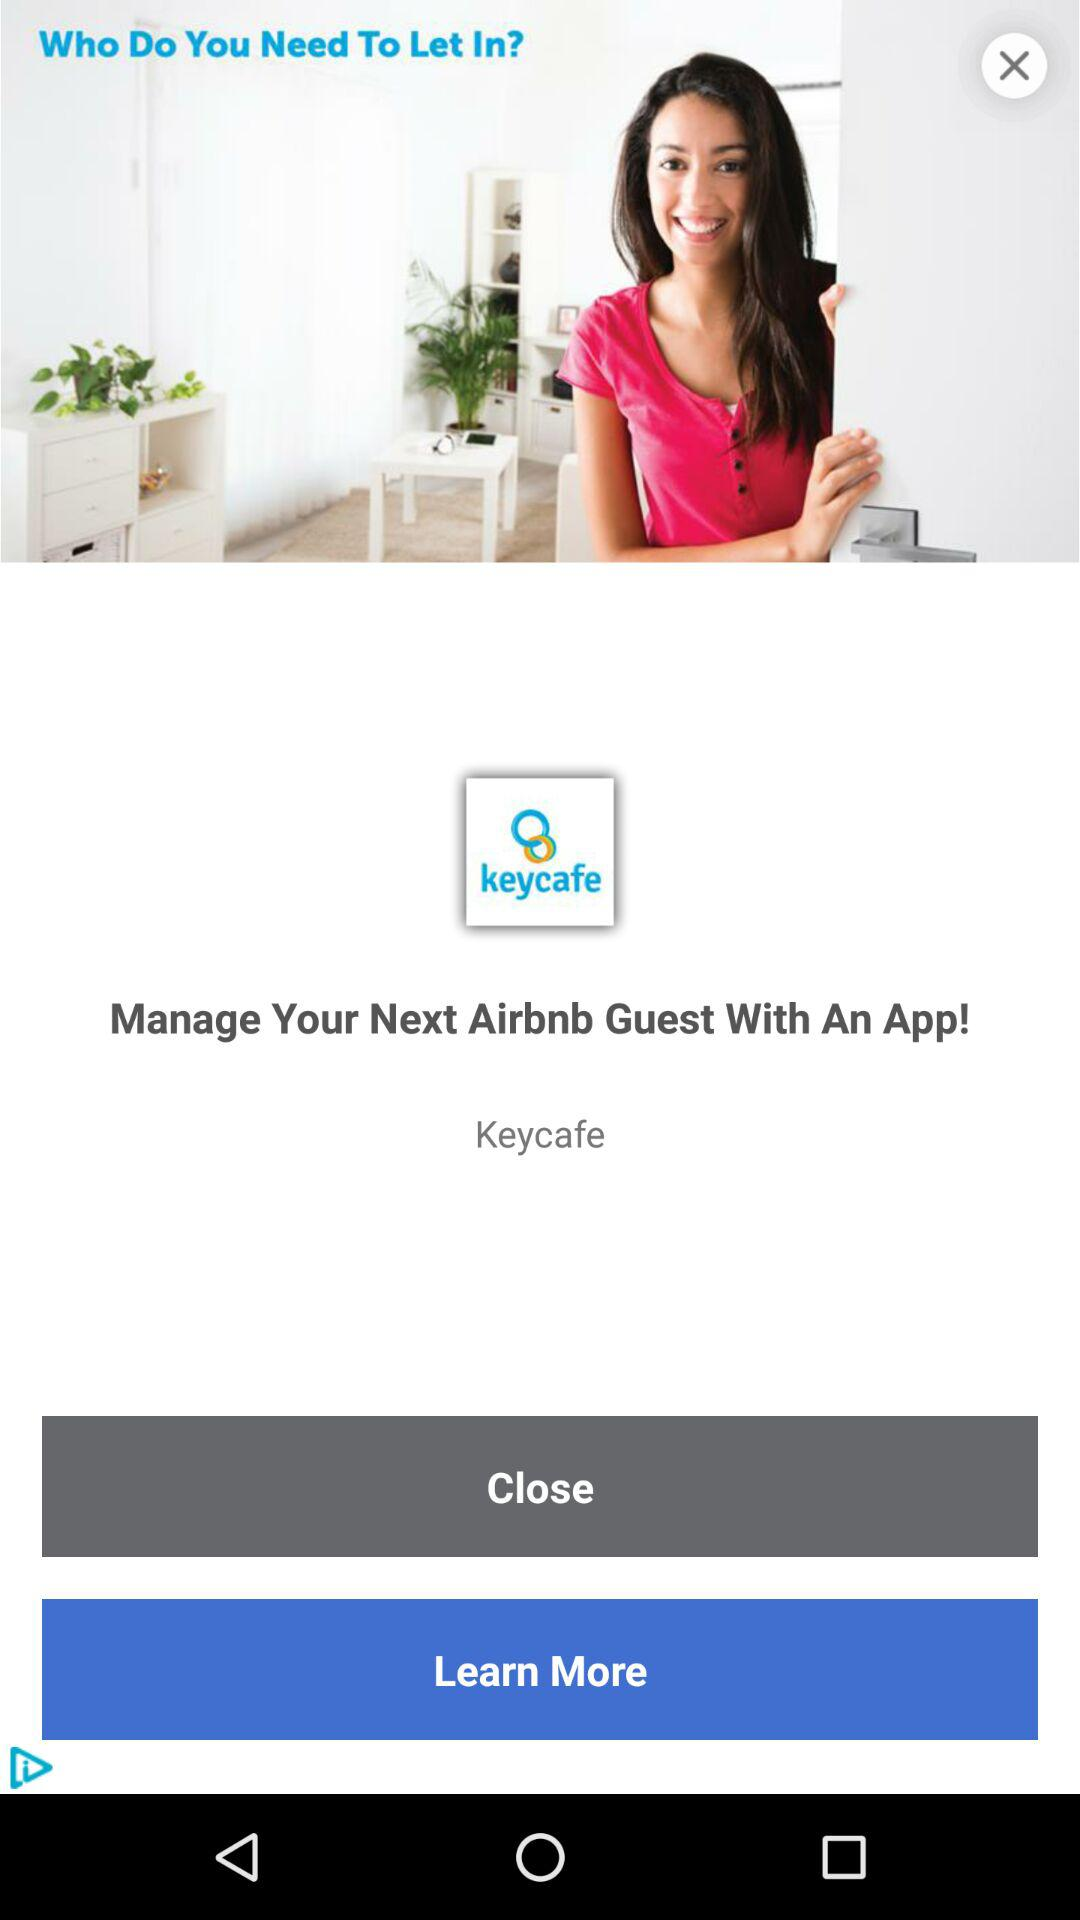What is the application name? The application name is "Keycafe". 